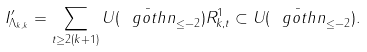Convert formula to latex. <formula><loc_0><loc_0><loc_500><loc_500>I _ { \Lambda _ { k , k } } ^ { \prime } = \sum _ { t \geq 2 ( k + 1 ) } U ( \bar { \ g o t h { n } } _ { \leq - 2 } ) R _ { k , t } ^ { 1 } \subset U ( \bar { \ g o t h { n } } _ { \leq - 2 } ) .</formula> 